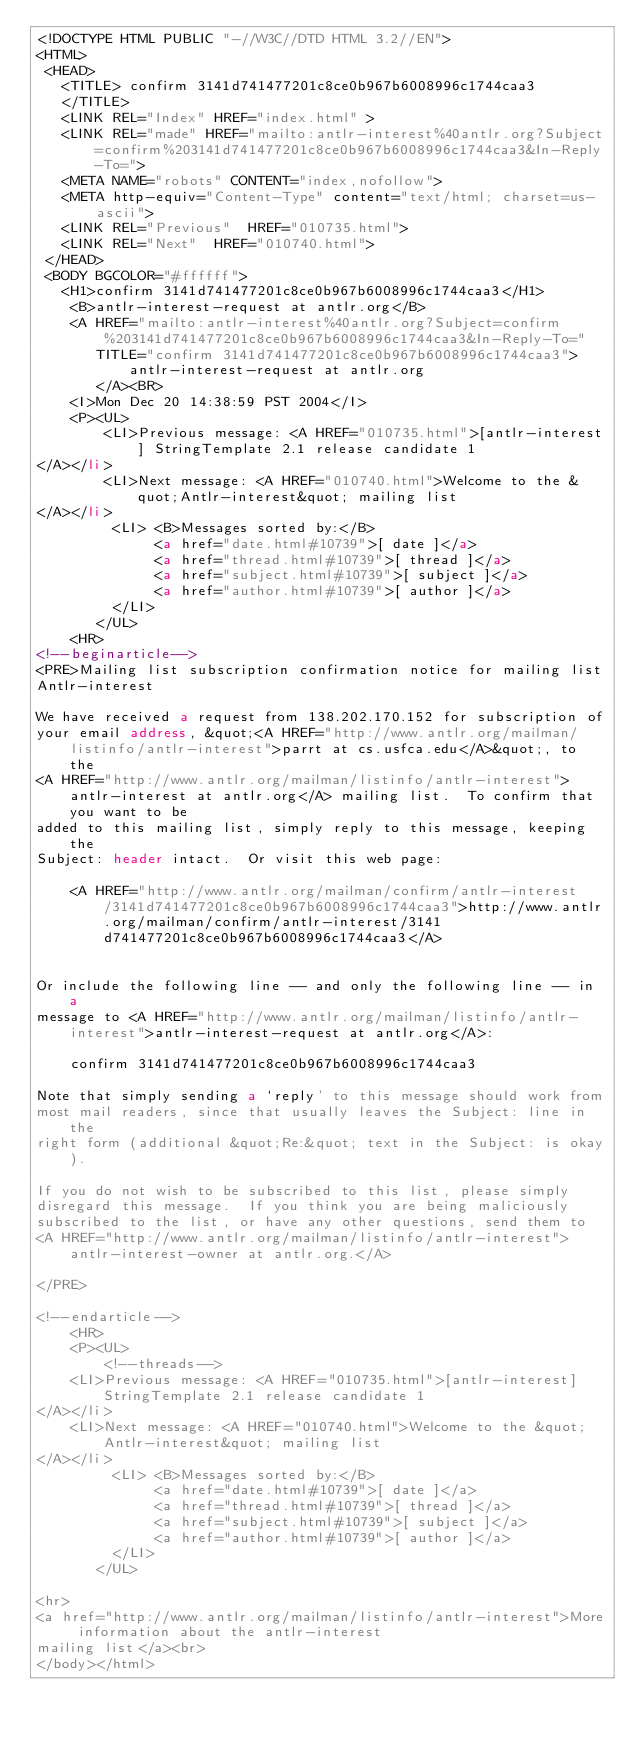Convert code to text. <code><loc_0><loc_0><loc_500><loc_500><_HTML_><!DOCTYPE HTML PUBLIC "-//W3C//DTD HTML 3.2//EN">
<HTML>
 <HEAD>
   <TITLE> confirm 3141d741477201c8ce0b967b6008996c1744caa3
   </TITLE>
   <LINK REL="Index" HREF="index.html" >
   <LINK REL="made" HREF="mailto:antlr-interest%40antlr.org?Subject=confirm%203141d741477201c8ce0b967b6008996c1744caa3&In-Reply-To=">
   <META NAME="robots" CONTENT="index,nofollow">
   <META http-equiv="Content-Type" content="text/html; charset=us-ascii">
   <LINK REL="Previous"  HREF="010735.html">
   <LINK REL="Next"  HREF="010740.html">
 </HEAD>
 <BODY BGCOLOR="#ffffff">
   <H1>confirm 3141d741477201c8ce0b967b6008996c1744caa3</H1>
    <B>antlr-interest-request at antlr.org</B> 
    <A HREF="mailto:antlr-interest%40antlr.org?Subject=confirm%203141d741477201c8ce0b967b6008996c1744caa3&In-Reply-To="
       TITLE="confirm 3141d741477201c8ce0b967b6008996c1744caa3">antlr-interest-request at antlr.org
       </A><BR>
    <I>Mon Dec 20 14:38:59 PST 2004</I>
    <P><UL>
        <LI>Previous message: <A HREF="010735.html">[antlr-interest] StringTemplate 2.1 release candidate 1
</A></li>
        <LI>Next message: <A HREF="010740.html">Welcome to the &quot;Antlr-interest&quot; mailing list
</A></li>
         <LI> <B>Messages sorted by:</B> 
              <a href="date.html#10739">[ date ]</a>
              <a href="thread.html#10739">[ thread ]</a>
              <a href="subject.html#10739">[ subject ]</a>
              <a href="author.html#10739">[ author ]</a>
         </LI>
       </UL>
    <HR>  
<!--beginarticle-->
<PRE>Mailing list subscription confirmation notice for mailing list
Antlr-interest

We have received a request from 138.202.170.152 for subscription of
your email address, &quot;<A HREF="http://www.antlr.org/mailman/listinfo/antlr-interest">parrt at cs.usfca.edu</A>&quot;, to the
<A HREF="http://www.antlr.org/mailman/listinfo/antlr-interest">antlr-interest at antlr.org</A> mailing list.  To confirm that you want to be
added to this mailing list, simply reply to this message, keeping the
Subject: header intact.  Or visit this web page:

    <A HREF="http://www.antlr.org/mailman/confirm/antlr-interest/3141d741477201c8ce0b967b6008996c1744caa3">http://www.antlr.org/mailman/confirm/antlr-interest/3141d741477201c8ce0b967b6008996c1744caa3</A>


Or include the following line -- and only the following line -- in a
message to <A HREF="http://www.antlr.org/mailman/listinfo/antlr-interest">antlr-interest-request at antlr.org</A>:

    confirm 3141d741477201c8ce0b967b6008996c1744caa3

Note that simply sending a `reply' to this message should work from
most mail readers, since that usually leaves the Subject: line in the
right form (additional &quot;Re:&quot; text in the Subject: is okay).

If you do not wish to be subscribed to this list, please simply
disregard this message.  If you think you are being maliciously
subscribed to the list, or have any other questions, send them to
<A HREF="http://www.antlr.org/mailman/listinfo/antlr-interest">antlr-interest-owner at antlr.org.</A>

</PRE>

<!--endarticle-->
    <HR>
    <P><UL>
        <!--threads-->
	<LI>Previous message: <A HREF="010735.html">[antlr-interest] StringTemplate 2.1 release candidate 1
</A></li>
	<LI>Next message: <A HREF="010740.html">Welcome to the &quot;Antlr-interest&quot; mailing list
</A></li>
         <LI> <B>Messages sorted by:</B> 
              <a href="date.html#10739">[ date ]</a>
              <a href="thread.html#10739">[ thread ]</a>
              <a href="subject.html#10739">[ subject ]</a>
              <a href="author.html#10739">[ author ]</a>
         </LI>
       </UL>

<hr>
<a href="http://www.antlr.org/mailman/listinfo/antlr-interest">More information about the antlr-interest
mailing list</a><br>
</body></html>
</code> 